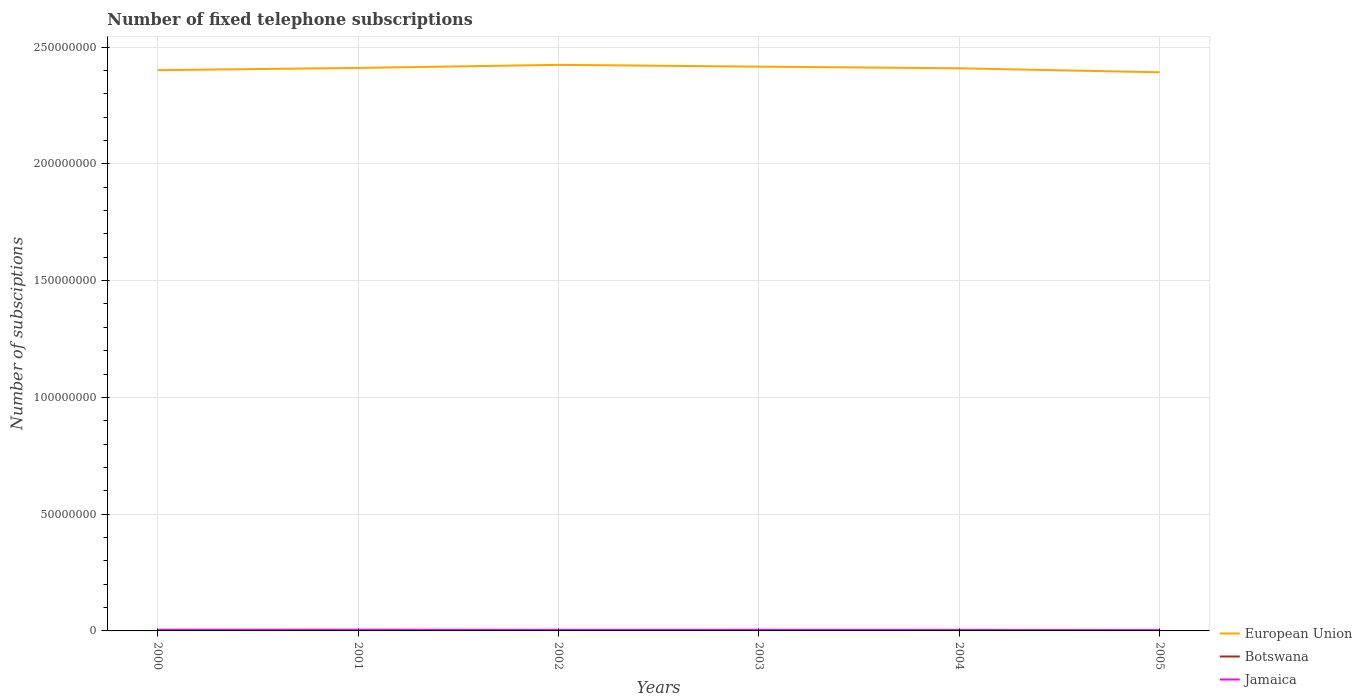Is the number of lines equal to the number of legend labels?
Ensure brevity in your answer.  Yes. Across all years, what is the maximum number of fixed telephone subscriptions in Jamaica?
Your response must be concise. 3.19e+05. In which year was the number of fixed telephone subscriptions in Botswana maximum?
Provide a succinct answer. 2003. What is the total number of fixed telephone subscriptions in Botswana in the graph?
Provide a short and direct response. -375. What is the difference between the highest and the second highest number of fixed telephone subscriptions in Jamaica?
Your answer should be very brief. 1.92e+05. Is the number of fixed telephone subscriptions in Jamaica strictly greater than the number of fixed telephone subscriptions in Botswana over the years?
Offer a terse response. No. What is the difference between two consecutive major ticks on the Y-axis?
Offer a terse response. 5.00e+07. Where does the legend appear in the graph?
Keep it short and to the point. Bottom right. How many legend labels are there?
Keep it short and to the point. 3. What is the title of the graph?
Keep it short and to the point. Number of fixed telephone subscriptions. Does "Maldives" appear as one of the legend labels in the graph?
Give a very brief answer. No. What is the label or title of the X-axis?
Keep it short and to the point. Years. What is the label or title of the Y-axis?
Keep it short and to the point. Number of subsciptions. What is the Number of subsciptions of European Union in 2000?
Provide a succinct answer. 2.40e+08. What is the Number of subsciptions of Botswana in 2000?
Provide a short and direct response. 1.36e+05. What is the Number of subsciptions in Jamaica in 2000?
Offer a very short reply. 4.94e+05. What is the Number of subsciptions of European Union in 2001?
Your answer should be very brief. 2.41e+08. What is the Number of subsciptions of Botswana in 2001?
Keep it short and to the point. 1.48e+05. What is the Number of subsciptions in Jamaica in 2001?
Your answer should be compact. 5.11e+05. What is the Number of subsciptions in European Union in 2002?
Provide a short and direct response. 2.42e+08. What is the Number of subsciptions of Botswana in 2002?
Your answer should be compact. 1.48e+05. What is the Number of subsciptions of Jamaica in 2002?
Your answer should be compact. 4.35e+05. What is the Number of subsciptions in European Union in 2003?
Provide a succinct answer. 2.42e+08. What is the Number of subsciptions in Botswana in 2003?
Ensure brevity in your answer.  1.31e+05. What is the Number of subsciptions in Jamaica in 2003?
Provide a short and direct response. 4.59e+05. What is the Number of subsciptions in European Union in 2004?
Offer a terse response. 2.41e+08. What is the Number of subsciptions of Botswana in 2004?
Give a very brief answer. 1.32e+05. What is the Number of subsciptions in Jamaica in 2004?
Offer a very short reply. 4.23e+05. What is the Number of subsciptions in European Union in 2005?
Make the answer very short. 2.39e+08. What is the Number of subsciptions of Botswana in 2005?
Your answer should be compact. 1.36e+05. What is the Number of subsciptions of Jamaica in 2005?
Offer a terse response. 3.19e+05. Across all years, what is the maximum Number of subsciptions of European Union?
Provide a succinct answer. 2.42e+08. Across all years, what is the maximum Number of subsciptions of Botswana?
Offer a terse response. 1.48e+05. Across all years, what is the maximum Number of subsciptions of Jamaica?
Your response must be concise. 5.11e+05. Across all years, what is the minimum Number of subsciptions of European Union?
Provide a succinct answer. 2.39e+08. Across all years, what is the minimum Number of subsciptions in Botswana?
Ensure brevity in your answer.  1.31e+05. Across all years, what is the minimum Number of subsciptions in Jamaica?
Make the answer very short. 3.19e+05. What is the total Number of subsciptions in European Union in the graph?
Keep it short and to the point. 1.45e+09. What is the total Number of subsciptions in Botswana in the graph?
Your answer should be compact. 8.32e+05. What is the total Number of subsciptions of Jamaica in the graph?
Ensure brevity in your answer.  2.64e+06. What is the difference between the Number of subsciptions in European Union in 2000 and that in 2001?
Provide a short and direct response. -9.60e+05. What is the difference between the Number of subsciptions in Botswana in 2000 and that in 2001?
Give a very brief answer. -1.23e+04. What is the difference between the Number of subsciptions of Jamaica in 2000 and that in 2001?
Offer a very short reply. -1.78e+04. What is the difference between the Number of subsciptions of European Union in 2000 and that in 2002?
Your response must be concise. -2.27e+06. What is the difference between the Number of subsciptions in Botswana in 2000 and that in 2002?
Ensure brevity in your answer.  -1.23e+04. What is the difference between the Number of subsciptions in Jamaica in 2000 and that in 2002?
Your response must be concise. 5.88e+04. What is the difference between the Number of subsciptions of European Union in 2000 and that in 2003?
Keep it short and to the point. -1.51e+06. What is the difference between the Number of subsciptions of Botswana in 2000 and that in 2003?
Provide a short and direct response. 4501. What is the difference between the Number of subsciptions of Jamaica in 2000 and that in 2003?
Offer a terse response. 3.48e+04. What is the difference between the Number of subsciptions in European Union in 2000 and that in 2004?
Your response must be concise. -8.04e+05. What is the difference between the Number of subsciptions of Botswana in 2000 and that in 2004?
Make the answer very short. 4126. What is the difference between the Number of subsciptions in Jamaica in 2000 and that in 2004?
Your response must be concise. 7.05e+04. What is the difference between the Number of subsciptions of European Union in 2000 and that in 2005?
Ensure brevity in your answer.  9.13e+05. What is the difference between the Number of subsciptions of Botswana in 2000 and that in 2005?
Provide a succinct answer. -563. What is the difference between the Number of subsciptions in Jamaica in 2000 and that in 2005?
Offer a very short reply. 1.75e+05. What is the difference between the Number of subsciptions of European Union in 2001 and that in 2002?
Offer a very short reply. -1.31e+06. What is the difference between the Number of subsciptions in Botswana in 2001 and that in 2002?
Provide a short and direct response. 0. What is the difference between the Number of subsciptions in Jamaica in 2001 and that in 2002?
Give a very brief answer. 7.65e+04. What is the difference between the Number of subsciptions of European Union in 2001 and that in 2003?
Provide a short and direct response. -5.47e+05. What is the difference between the Number of subsciptions of Botswana in 2001 and that in 2003?
Ensure brevity in your answer.  1.68e+04. What is the difference between the Number of subsciptions in Jamaica in 2001 and that in 2003?
Provide a short and direct response. 5.26e+04. What is the difference between the Number of subsciptions of European Union in 2001 and that in 2004?
Your answer should be compact. 1.56e+05. What is the difference between the Number of subsciptions of Botswana in 2001 and that in 2004?
Your response must be concise. 1.64e+04. What is the difference between the Number of subsciptions in Jamaica in 2001 and that in 2004?
Keep it short and to the point. 8.83e+04. What is the difference between the Number of subsciptions of European Union in 2001 and that in 2005?
Make the answer very short. 1.87e+06. What is the difference between the Number of subsciptions of Botswana in 2001 and that in 2005?
Offer a terse response. 1.17e+04. What is the difference between the Number of subsciptions in Jamaica in 2001 and that in 2005?
Your answer should be compact. 1.92e+05. What is the difference between the Number of subsciptions in European Union in 2002 and that in 2003?
Offer a terse response. 7.60e+05. What is the difference between the Number of subsciptions of Botswana in 2002 and that in 2003?
Provide a succinct answer. 1.68e+04. What is the difference between the Number of subsciptions of Jamaica in 2002 and that in 2003?
Give a very brief answer. -2.39e+04. What is the difference between the Number of subsciptions of European Union in 2002 and that in 2004?
Provide a succinct answer. 1.46e+06. What is the difference between the Number of subsciptions in Botswana in 2002 and that in 2004?
Offer a very short reply. 1.64e+04. What is the difference between the Number of subsciptions in Jamaica in 2002 and that in 2004?
Provide a succinct answer. 1.18e+04. What is the difference between the Number of subsciptions in European Union in 2002 and that in 2005?
Give a very brief answer. 3.18e+06. What is the difference between the Number of subsciptions in Botswana in 2002 and that in 2005?
Your answer should be compact. 1.17e+04. What is the difference between the Number of subsciptions of Jamaica in 2002 and that in 2005?
Provide a short and direct response. 1.16e+05. What is the difference between the Number of subsciptions in European Union in 2003 and that in 2004?
Your response must be concise. 7.04e+05. What is the difference between the Number of subsciptions in Botswana in 2003 and that in 2004?
Offer a very short reply. -375. What is the difference between the Number of subsciptions in Jamaica in 2003 and that in 2004?
Give a very brief answer. 3.57e+04. What is the difference between the Number of subsciptions of European Union in 2003 and that in 2005?
Your answer should be compact. 2.42e+06. What is the difference between the Number of subsciptions in Botswana in 2003 and that in 2005?
Make the answer very short. -5064. What is the difference between the Number of subsciptions of Jamaica in 2003 and that in 2005?
Provide a short and direct response. 1.40e+05. What is the difference between the Number of subsciptions of European Union in 2004 and that in 2005?
Offer a very short reply. 1.72e+06. What is the difference between the Number of subsciptions of Botswana in 2004 and that in 2005?
Provide a succinct answer. -4689. What is the difference between the Number of subsciptions in Jamaica in 2004 and that in 2005?
Ensure brevity in your answer.  1.04e+05. What is the difference between the Number of subsciptions of European Union in 2000 and the Number of subsciptions of Botswana in 2001?
Make the answer very short. 2.40e+08. What is the difference between the Number of subsciptions in European Union in 2000 and the Number of subsciptions in Jamaica in 2001?
Ensure brevity in your answer.  2.40e+08. What is the difference between the Number of subsciptions in Botswana in 2000 and the Number of subsciptions in Jamaica in 2001?
Keep it short and to the point. -3.75e+05. What is the difference between the Number of subsciptions of European Union in 2000 and the Number of subsciptions of Botswana in 2002?
Provide a succinct answer. 2.40e+08. What is the difference between the Number of subsciptions in European Union in 2000 and the Number of subsciptions in Jamaica in 2002?
Ensure brevity in your answer.  2.40e+08. What is the difference between the Number of subsciptions in Botswana in 2000 and the Number of subsciptions in Jamaica in 2002?
Provide a short and direct response. -2.99e+05. What is the difference between the Number of subsciptions in European Union in 2000 and the Number of subsciptions in Botswana in 2003?
Offer a very short reply. 2.40e+08. What is the difference between the Number of subsciptions of European Union in 2000 and the Number of subsciptions of Jamaica in 2003?
Keep it short and to the point. 2.40e+08. What is the difference between the Number of subsciptions in Botswana in 2000 and the Number of subsciptions in Jamaica in 2003?
Your response must be concise. -3.23e+05. What is the difference between the Number of subsciptions of European Union in 2000 and the Number of subsciptions of Botswana in 2004?
Give a very brief answer. 2.40e+08. What is the difference between the Number of subsciptions of European Union in 2000 and the Number of subsciptions of Jamaica in 2004?
Make the answer very short. 2.40e+08. What is the difference between the Number of subsciptions in Botswana in 2000 and the Number of subsciptions in Jamaica in 2004?
Offer a very short reply. -2.87e+05. What is the difference between the Number of subsciptions of European Union in 2000 and the Number of subsciptions of Botswana in 2005?
Ensure brevity in your answer.  2.40e+08. What is the difference between the Number of subsciptions in European Union in 2000 and the Number of subsciptions in Jamaica in 2005?
Make the answer very short. 2.40e+08. What is the difference between the Number of subsciptions in Botswana in 2000 and the Number of subsciptions in Jamaica in 2005?
Make the answer very short. -1.83e+05. What is the difference between the Number of subsciptions in European Union in 2001 and the Number of subsciptions in Botswana in 2002?
Give a very brief answer. 2.41e+08. What is the difference between the Number of subsciptions of European Union in 2001 and the Number of subsciptions of Jamaica in 2002?
Your answer should be compact. 2.41e+08. What is the difference between the Number of subsciptions of Botswana in 2001 and the Number of subsciptions of Jamaica in 2002?
Make the answer very short. -2.87e+05. What is the difference between the Number of subsciptions in European Union in 2001 and the Number of subsciptions in Botswana in 2003?
Provide a succinct answer. 2.41e+08. What is the difference between the Number of subsciptions of European Union in 2001 and the Number of subsciptions of Jamaica in 2003?
Your answer should be compact. 2.41e+08. What is the difference between the Number of subsciptions of Botswana in 2001 and the Number of subsciptions of Jamaica in 2003?
Provide a short and direct response. -3.11e+05. What is the difference between the Number of subsciptions of European Union in 2001 and the Number of subsciptions of Botswana in 2004?
Keep it short and to the point. 2.41e+08. What is the difference between the Number of subsciptions of European Union in 2001 and the Number of subsciptions of Jamaica in 2004?
Offer a terse response. 2.41e+08. What is the difference between the Number of subsciptions of Botswana in 2001 and the Number of subsciptions of Jamaica in 2004?
Provide a short and direct response. -2.75e+05. What is the difference between the Number of subsciptions in European Union in 2001 and the Number of subsciptions in Botswana in 2005?
Offer a terse response. 2.41e+08. What is the difference between the Number of subsciptions of European Union in 2001 and the Number of subsciptions of Jamaica in 2005?
Give a very brief answer. 2.41e+08. What is the difference between the Number of subsciptions of Botswana in 2001 and the Number of subsciptions of Jamaica in 2005?
Offer a terse response. -1.71e+05. What is the difference between the Number of subsciptions in European Union in 2002 and the Number of subsciptions in Botswana in 2003?
Provide a short and direct response. 2.42e+08. What is the difference between the Number of subsciptions in European Union in 2002 and the Number of subsciptions in Jamaica in 2003?
Make the answer very short. 2.42e+08. What is the difference between the Number of subsciptions of Botswana in 2002 and the Number of subsciptions of Jamaica in 2003?
Keep it short and to the point. -3.11e+05. What is the difference between the Number of subsciptions of European Union in 2002 and the Number of subsciptions of Botswana in 2004?
Your answer should be very brief. 2.42e+08. What is the difference between the Number of subsciptions of European Union in 2002 and the Number of subsciptions of Jamaica in 2004?
Offer a terse response. 2.42e+08. What is the difference between the Number of subsciptions of Botswana in 2002 and the Number of subsciptions of Jamaica in 2004?
Your answer should be compact. -2.75e+05. What is the difference between the Number of subsciptions in European Union in 2002 and the Number of subsciptions in Botswana in 2005?
Your answer should be very brief. 2.42e+08. What is the difference between the Number of subsciptions in European Union in 2002 and the Number of subsciptions in Jamaica in 2005?
Offer a very short reply. 2.42e+08. What is the difference between the Number of subsciptions in Botswana in 2002 and the Number of subsciptions in Jamaica in 2005?
Your answer should be very brief. -1.71e+05. What is the difference between the Number of subsciptions of European Union in 2003 and the Number of subsciptions of Botswana in 2004?
Provide a succinct answer. 2.41e+08. What is the difference between the Number of subsciptions in European Union in 2003 and the Number of subsciptions in Jamaica in 2004?
Give a very brief answer. 2.41e+08. What is the difference between the Number of subsciptions of Botswana in 2003 and the Number of subsciptions of Jamaica in 2004?
Make the answer very short. -2.92e+05. What is the difference between the Number of subsciptions of European Union in 2003 and the Number of subsciptions of Botswana in 2005?
Offer a terse response. 2.41e+08. What is the difference between the Number of subsciptions in European Union in 2003 and the Number of subsciptions in Jamaica in 2005?
Offer a very short reply. 2.41e+08. What is the difference between the Number of subsciptions in Botswana in 2003 and the Number of subsciptions in Jamaica in 2005?
Give a very brief answer. -1.88e+05. What is the difference between the Number of subsciptions of European Union in 2004 and the Number of subsciptions of Botswana in 2005?
Your answer should be very brief. 2.41e+08. What is the difference between the Number of subsciptions in European Union in 2004 and the Number of subsciptions in Jamaica in 2005?
Your answer should be compact. 2.41e+08. What is the difference between the Number of subsciptions in Botswana in 2004 and the Number of subsciptions in Jamaica in 2005?
Offer a very short reply. -1.87e+05. What is the average Number of subsciptions in European Union per year?
Keep it short and to the point. 2.41e+08. What is the average Number of subsciptions in Botswana per year?
Your response must be concise. 1.39e+05. What is the average Number of subsciptions of Jamaica per year?
Provide a succinct answer. 4.40e+05. In the year 2000, what is the difference between the Number of subsciptions of European Union and Number of subsciptions of Botswana?
Your answer should be very brief. 2.40e+08. In the year 2000, what is the difference between the Number of subsciptions of European Union and Number of subsciptions of Jamaica?
Provide a short and direct response. 2.40e+08. In the year 2000, what is the difference between the Number of subsciptions in Botswana and Number of subsciptions in Jamaica?
Give a very brief answer. -3.58e+05. In the year 2001, what is the difference between the Number of subsciptions in European Union and Number of subsciptions in Botswana?
Ensure brevity in your answer.  2.41e+08. In the year 2001, what is the difference between the Number of subsciptions in European Union and Number of subsciptions in Jamaica?
Your answer should be compact. 2.41e+08. In the year 2001, what is the difference between the Number of subsciptions in Botswana and Number of subsciptions in Jamaica?
Offer a terse response. -3.63e+05. In the year 2002, what is the difference between the Number of subsciptions in European Union and Number of subsciptions in Botswana?
Your response must be concise. 2.42e+08. In the year 2002, what is the difference between the Number of subsciptions of European Union and Number of subsciptions of Jamaica?
Offer a very short reply. 2.42e+08. In the year 2002, what is the difference between the Number of subsciptions in Botswana and Number of subsciptions in Jamaica?
Your response must be concise. -2.87e+05. In the year 2003, what is the difference between the Number of subsciptions of European Union and Number of subsciptions of Botswana?
Provide a short and direct response. 2.41e+08. In the year 2003, what is the difference between the Number of subsciptions in European Union and Number of subsciptions in Jamaica?
Make the answer very short. 2.41e+08. In the year 2003, what is the difference between the Number of subsciptions in Botswana and Number of subsciptions in Jamaica?
Keep it short and to the point. -3.27e+05. In the year 2004, what is the difference between the Number of subsciptions of European Union and Number of subsciptions of Botswana?
Keep it short and to the point. 2.41e+08. In the year 2004, what is the difference between the Number of subsciptions in European Union and Number of subsciptions in Jamaica?
Make the answer very short. 2.40e+08. In the year 2004, what is the difference between the Number of subsciptions in Botswana and Number of subsciptions in Jamaica?
Your answer should be very brief. -2.91e+05. In the year 2005, what is the difference between the Number of subsciptions in European Union and Number of subsciptions in Botswana?
Your answer should be compact. 2.39e+08. In the year 2005, what is the difference between the Number of subsciptions of European Union and Number of subsciptions of Jamaica?
Ensure brevity in your answer.  2.39e+08. In the year 2005, what is the difference between the Number of subsciptions of Botswana and Number of subsciptions of Jamaica?
Keep it short and to the point. -1.83e+05. What is the ratio of the Number of subsciptions of Botswana in 2000 to that in 2001?
Provide a succinct answer. 0.92. What is the ratio of the Number of subsciptions of Jamaica in 2000 to that in 2001?
Ensure brevity in your answer.  0.97. What is the ratio of the Number of subsciptions in European Union in 2000 to that in 2002?
Offer a terse response. 0.99. What is the ratio of the Number of subsciptions of Botswana in 2000 to that in 2002?
Your answer should be very brief. 0.92. What is the ratio of the Number of subsciptions in Jamaica in 2000 to that in 2002?
Provide a succinct answer. 1.14. What is the ratio of the Number of subsciptions in European Union in 2000 to that in 2003?
Ensure brevity in your answer.  0.99. What is the ratio of the Number of subsciptions of Botswana in 2000 to that in 2003?
Your answer should be very brief. 1.03. What is the ratio of the Number of subsciptions of Jamaica in 2000 to that in 2003?
Your response must be concise. 1.08. What is the ratio of the Number of subsciptions of Botswana in 2000 to that in 2004?
Keep it short and to the point. 1.03. What is the ratio of the Number of subsciptions of European Union in 2000 to that in 2005?
Your response must be concise. 1. What is the ratio of the Number of subsciptions in Jamaica in 2000 to that in 2005?
Provide a succinct answer. 1.55. What is the ratio of the Number of subsciptions of Jamaica in 2001 to that in 2002?
Your response must be concise. 1.18. What is the ratio of the Number of subsciptions in European Union in 2001 to that in 2003?
Offer a very short reply. 1. What is the ratio of the Number of subsciptions of Botswana in 2001 to that in 2003?
Keep it short and to the point. 1.13. What is the ratio of the Number of subsciptions in Jamaica in 2001 to that in 2003?
Your response must be concise. 1.11. What is the ratio of the Number of subsciptions in European Union in 2001 to that in 2004?
Your response must be concise. 1. What is the ratio of the Number of subsciptions in Botswana in 2001 to that in 2004?
Offer a very short reply. 1.12. What is the ratio of the Number of subsciptions in Jamaica in 2001 to that in 2004?
Offer a very short reply. 1.21. What is the ratio of the Number of subsciptions in Botswana in 2001 to that in 2005?
Offer a terse response. 1.09. What is the ratio of the Number of subsciptions in Jamaica in 2001 to that in 2005?
Provide a succinct answer. 1.6. What is the ratio of the Number of subsciptions of European Union in 2002 to that in 2003?
Your response must be concise. 1. What is the ratio of the Number of subsciptions in Botswana in 2002 to that in 2003?
Your answer should be very brief. 1.13. What is the ratio of the Number of subsciptions of Jamaica in 2002 to that in 2003?
Offer a terse response. 0.95. What is the ratio of the Number of subsciptions of Botswana in 2002 to that in 2004?
Make the answer very short. 1.12. What is the ratio of the Number of subsciptions in Jamaica in 2002 to that in 2004?
Offer a very short reply. 1.03. What is the ratio of the Number of subsciptions of European Union in 2002 to that in 2005?
Offer a very short reply. 1.01. What is the ratio of the Number of subsciptions in Botswana in 2002 to that in 2005?
Provide a succinct answer. 1.09. What is the ratio of the Number of subsciptions of Jamaica in 2002 to that in 2005?
Your answer should be very brief. 1.36. What is the ratio of the Number of subsciptions of European Union in 2003 to that in 2004?
Keep it short and to the point. 1. What is the ratio of the Number of subsciptions of Jamaica in 2003 to that in 2004?
Offer a terse response. 1.08. What is the ratio of the Number of subsciptions of Botswana in 2003 to that in 2005?
Offer a very short reply. 0.96. What is the ratio of the Number of subsciptions in Jamaica in 2003 to that in 2005?
Provide a short and direct response. 1.44. What is the ratio of the Number of subsciptions of European Union in 2004 to that in 2005?
Keep it short and to the point. 1.01. What is the ratio of the Number of subsciptions of Botswana in 2004 to that in 2005?
Ensure brevity in your answer.  0.97. What is the ratio of the Number of subsciptions in Jamaica in 2004 to that in 2005?
Make the answer very short. 1.33. What is the difference between the highest and the second highest Number of subsciptions in European Union?
Your answer should be very brief. 7.60e+05. What is the difference between the highest and the second highest Number of subsciptions in Botswana?
Make the answer very short. 0. What is the difference between the highest and the second highest Number of subsciptions of Jamaica?
Ensure brevity in your answer.  1.78e+04. What is the difference between the highest and the lowest Number of subsciptions in European Union?
Your answer should be compact. 3.18e+06. What is the difference between the highest and the lowest Number of subsciptions of Botswana?
Provide a succinct answer. 1.68e+04. What is the difference between the highest and the lowest Number of subsciptions in Jamaica?
Keep it short and to the point. 1.92e+05. 